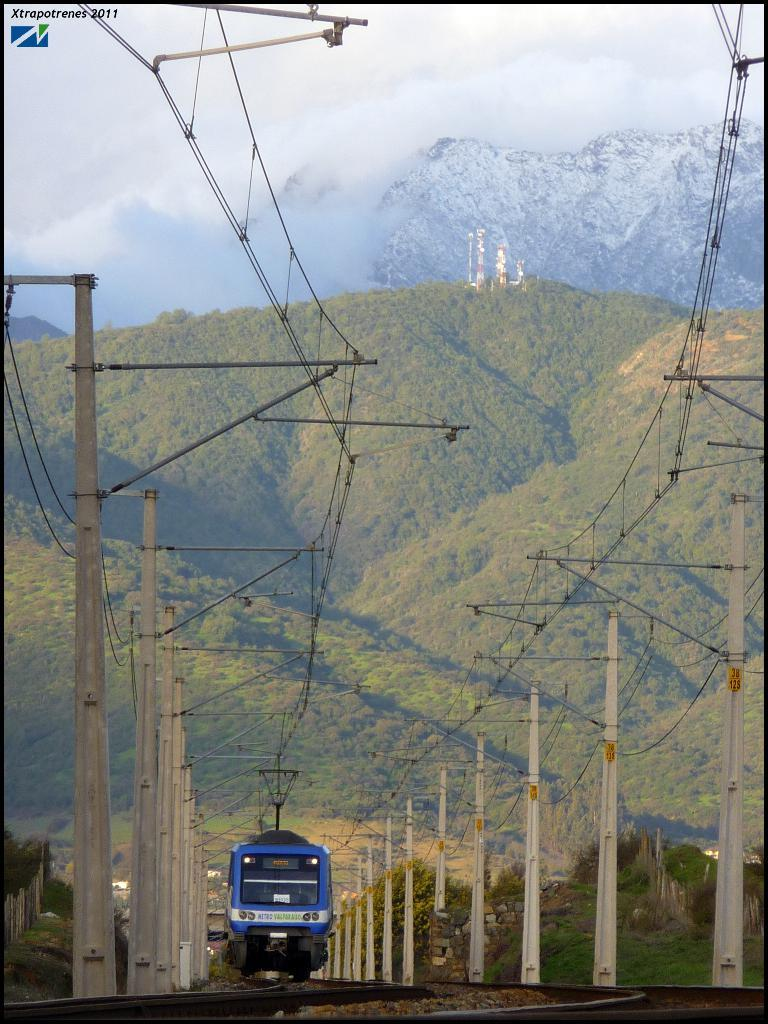What type of transportation infrastructure is present in the image? There are railway tracks in the image. What is traveling on the railway tracks? There is a blue color train on the railway tracks. What are some additional features visible in the image? There are poles, wires, clouds, trees, and mountains visible in the image. Where are the scissors located in the image? There are no scissors present in the image. What type of head is visible on the train in the image? The train in the image is a vehicle and does not have a head. 